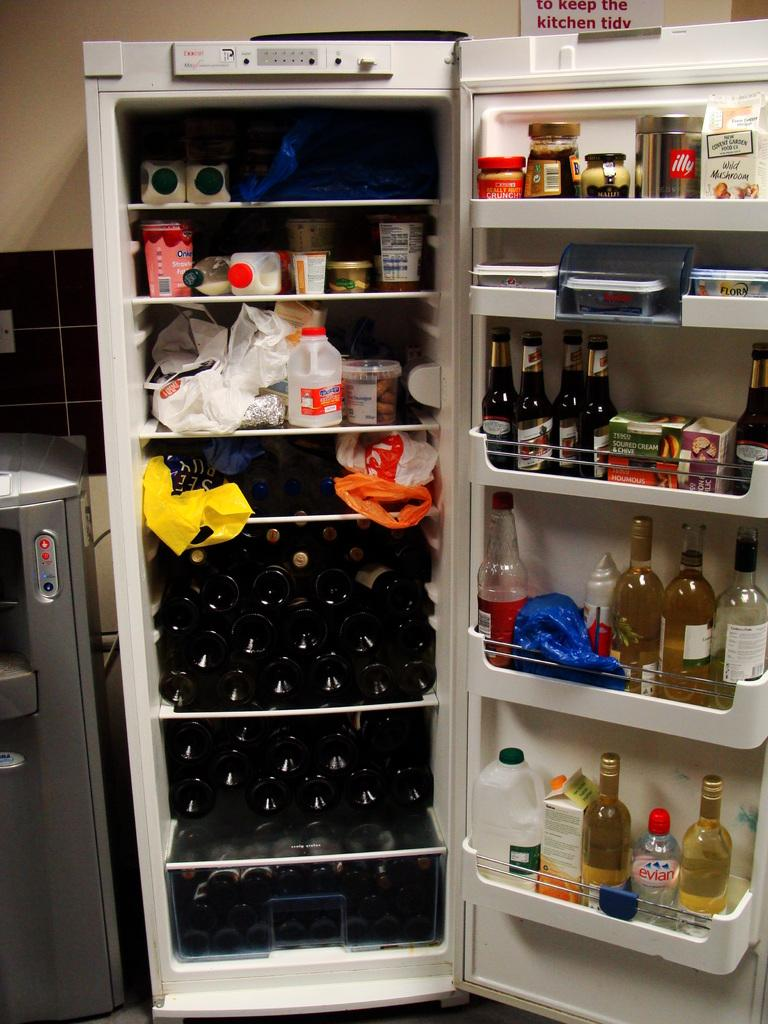<image>
Give a short and clear explanation of the subsequent image. An open fridge wine bottles filling up the bottom half and a sign behind that says to keep the kitchen tidy. 